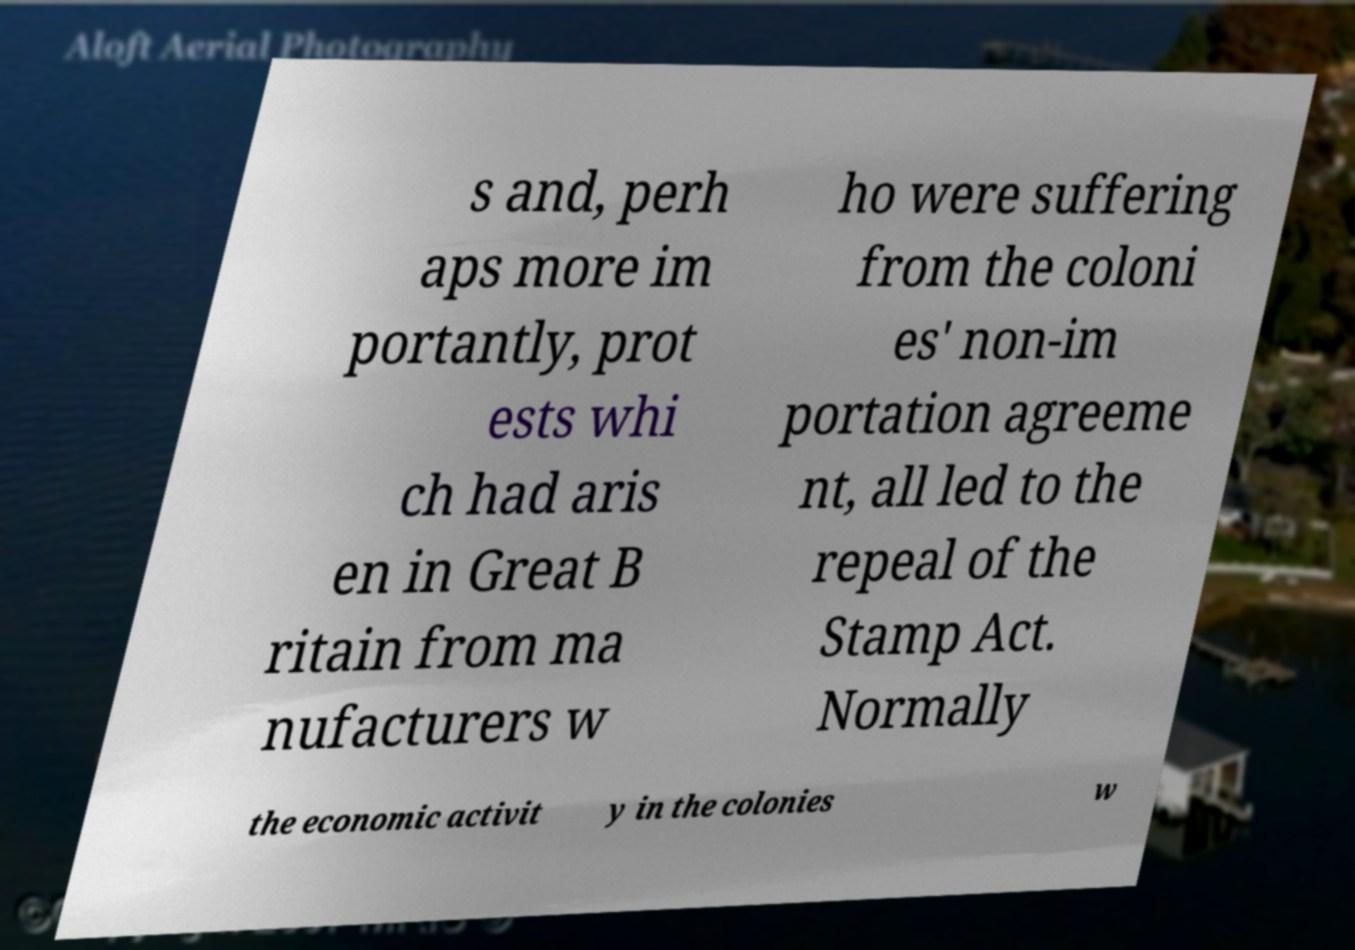I need the written content from this picture converted into text. Can you do that? s and, perh aps more im portantly, prot ests whi ch had aris en in Great B ritain from ma nufacturers w ho were suffering from the coloni es' non-im portation agreeme nt, all led to the repeal of the Stamp Act. Normally the economic activit y in the colonies w 